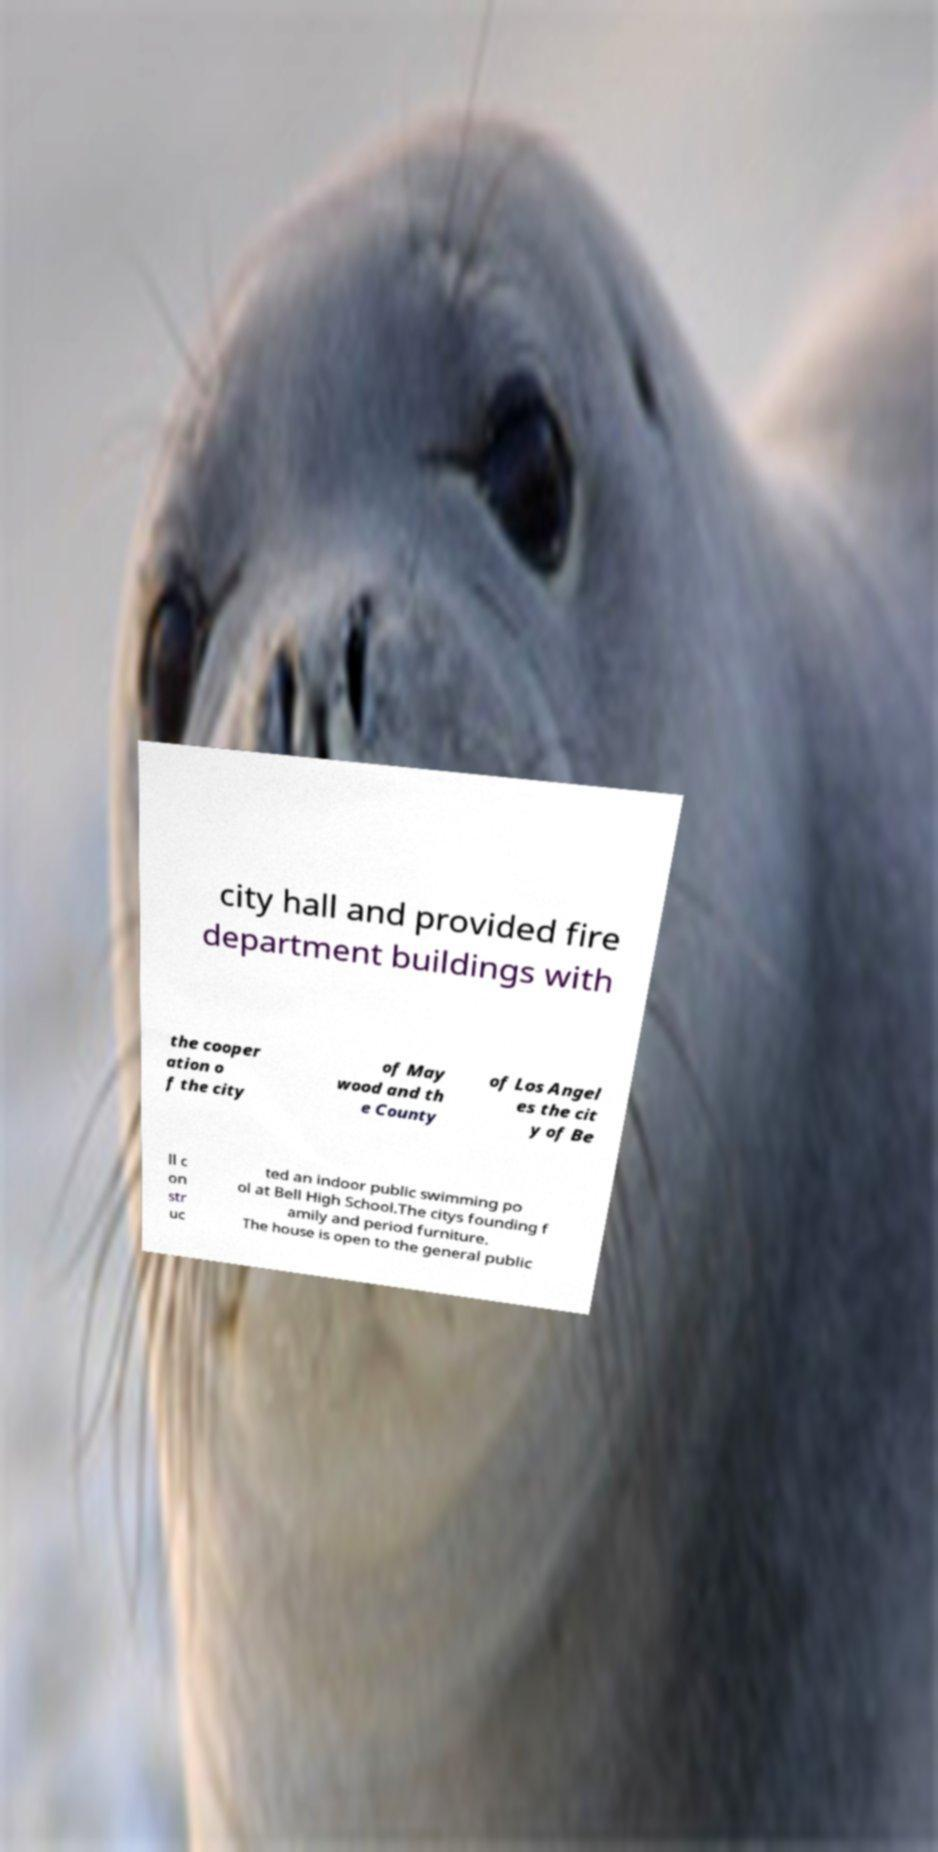What messages or text are displayed in this image? I need them in a readable, typed format. city hall and provided fire department buildings with the cooper ation o f the city of May wood and th e County of Los Angel es the cit y of Be ll c on str uc ted an indoor public swimming po ol at Bell High School.The citys founding f amily and period furniture. The house is open to the general public 